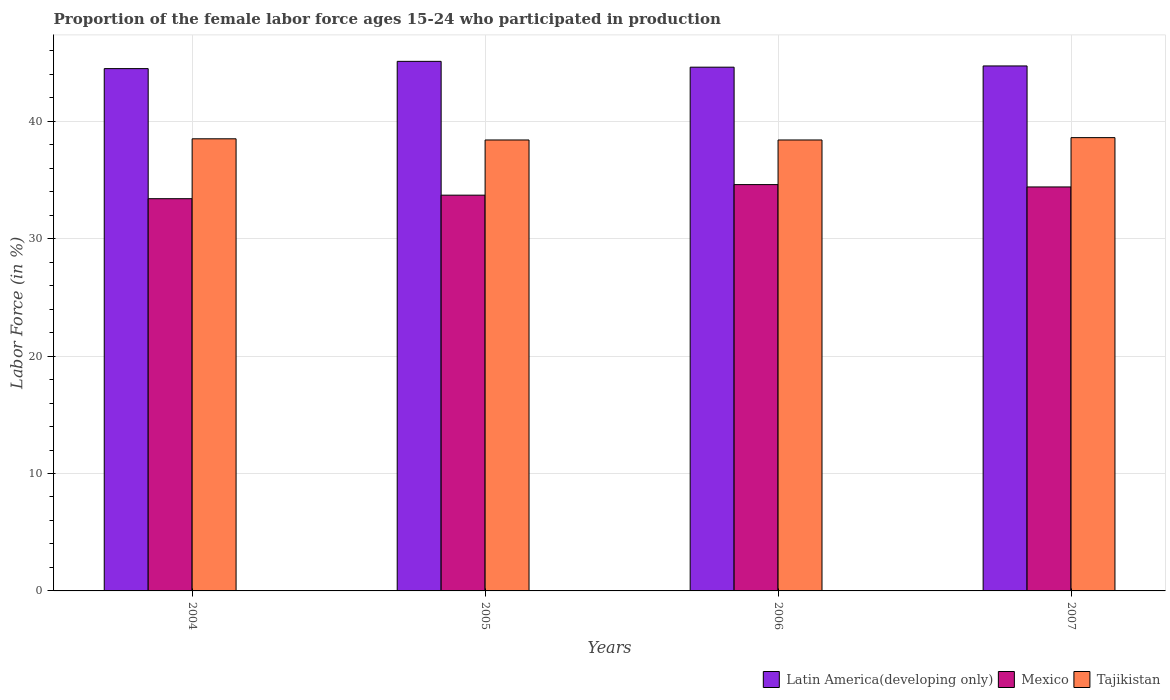How many different coloured bars are there?
Your response must be concise. 3. How many bars are there on the 1st tick from the right?
Offer a terse response. 3. What is the label of the 2nd group of bars from the left?
Your answer should be compact. 2005. In how many cases, is the number of bars for a given year not equal to the number of legend labels?
Provide a short and direct response. 0. What is the proportion of the female labor force who participated in production in Mexico in 2007?
Provide a succinct answer. 34.4. Across all years, what is the maximum proportion of the female labor force who participated in production in Latin America(developing only)?
Make the answer very short. 45.1. Across all years, what is the minimum proportion of the female labor force who participated in production in Mexico?
Your response must be concise. 33.4. In which year was the proportion of the female labor force who participated in production in Latin America(developing only) minimum?
Provide a succinct answer. 2004. What is the total proportion of the female labor force who participated in production in Mexico in the graph?
Offer a very short reply. 136.1. What is the difference between the proportion of the female labor force who participated in production in Tajikistan in 2004 and that in 2005?
Provide a short and direct response. 0.1. What is the difference between the proportion of the female labor force who participated in production in Mexico in 2005 and the proportion of the female labor force who participated in production in Tajikistan in 2004?
Provide a short and direct response. -4.8. What is the average proportion of the female labor force who participated in production in Tajikistan per year?
Your answer should be very brief. 38.48. In the year 2004, what is the difference between the proportion of the female labor force who participated in production in Tajikistan and proportion of the female labor force who participated in production in Latin America(developing only)?
Your answer should be compact. -5.98. In how many years, is the proportion of the female labor force who participated in production in Tajikistan greater than 30 %?
Your answer should be very brief. 4. What is the ratio of the proportion of the female labor force who participated in production in Latin America(developing only) in 2004 to that in 2005?
Make the answer very short. 0.99. Is the difference between the proportion of the female labor force who participated in production in Tajikistan in 2004 and 2006 greater than the difference between the proportion of the female labor force who participated in production in Latin America(developing only) in 2004 and 2006?
Keep it short and to the point. Yes. What is the difference between the highest and the second highest proportion of the female labor force who participated in production in Latin America(developing only)?
Give a very brief answer. 0.39. What is the difference between the highest and the lowest proportion of the female labor force who participated in production in Latin America(developing only)?
Provide a succinct answer. 0.62. What does the 3rd bar from the left in 2006 represents?
Ensure brevity in your answer.  Tajikistan. What does the 1st bar from the right in 2005 represents?
Offer a very short reply. Tajikistan. Is it the case that in every year, the sum of the proportion of the female labor force who participated in production in Mexico and proportion of the female labor force who participated in production in Latin America(developing only) is greater than the proportion of the female labor force who participated in production in Tajikistan?
Your response must be concise. Yes. Does the graph contain any zero values?
Offer a terse response. No. Does the graph contain grids?
Provide a short and direct response. Yes. Where does the legend appear in the graph?
Your response must be concise. Bottom right. How are the legend labels stacked?
Keep it short and to the point. Horizontal. What is the title of the graph?
Offer a terse response. Proportion of the female labor force ages 15-24 who participated in production. What is the Labor Force (in %) of Latin America(developing only) in 2004?
Offer a very short reply. 44.48. What is the Labor Force (in %) in Mexico in 2004?
Make the answer very short. 33.4. What is the Labor Force (in %) of Tajikistan in 2004?
Keep it short and to the point. 38.5. What is the Labor Force (in %) in Latin America(developing only) in 2005?
Provide a succinct answer. 45.1. What is the Labor Force (in %) in Mexico in 2005?
Provide a short and direct response. 33.7. What is the Labor Force (in %) in Tajikistan in 2005?
Keep it short and to the point. 38.4. What is the Labor Force (in %) of Latin America(developing only) in 2006?
Make the answer very short. 44.6. What is the Labor Force (in %) of Mexico in 2006?
Offer a terse response. 34.6. What is the Labor Force (in %) of Tajikistan in 2006?
Your answer should be compact. 38.4. What is the Labor Force (in %) of Latin America(developing only) in 2007?
Keep it short and to the point. 44.7. What is the Labor Force (in %) in Mexico in 2007?
Ensure brevity in your answer.  34.4. What is the Labor Force (in %) in Tajikistan in 2007?
Offer a very short reply. 38.6. Across all years, what is the maximum Labor Force (in %) in Latin America(developing only)?
Your answer should be compact. 45.1. Across all years, what is the maximum Labor Force (in %) of Mexico?
Your answer should be compact. 34.6. Across all years, what is the maximum Labor Force (in %) of Tajikistan?
Ensure brevity in your answer.  38.6. Across all years, what is the minimum Labor Force (in %) in Latin America(developing only)?
Make the answer very short. 44.48. Across all years, what is the minimum Labor Force (in %) in Mexico?
Ensure brevity in your answer.  33.4. Across all years, what is the minimum Labor Force (in %) in Tajikistan?
Provide a short and direct response. 38.4. What is the total Labor Force (in %) in Latin America(developing only) in the graph?
Provide a succinct answer. 178.88. What is the total Labor Force (in %) in Mexico in the graph?
Keep it short and to the point. 136.1. What is the total Labor Force (in %) of Tajikistan in the graph?
Offer a terse response. 153.9. What is the difference between the Labor Force (in %) of Latin America(developing only) in 2004 and that in 2005?
Keep it short and to the point. -0.62. What is the difference between the Labor Force (in %) in Latin America(developing only) in 2004 and that in 2006?
Make the answer very short. -0.12. What is the difference between the Labor Force (in %) of Latin America(developing only) in 2004 and that in 2007?
Give a very brief answer. -0.23. What is the difference between the Labor Force (in %) in Mexico in 2004 and that in 2007?
Your answer should be compact. -1. What is the difference between the Labor Force (in %) in Tajikistan in 2004 and that in 2007?
Give a very brief answer. -0.1. What is the difference between the Labor Force (in %) in Latin America(developing only) in 2005 and that in 2006?
Keep it short and to the point. 0.5. What is the difference between the Labor Force (in %) of Mexico in 2005 and that in 2006?
Your response must be concise. -0.9. What is the difference between the Labor Force (in %) in Tajikistan in 2005 and that in 2006?
Offer a terse response. 0. What is the difference between the Labor Force (in %) in Latin America(developing only) in 2005 and that in 2007?
Offer a very short reply. 0.39. What is the difference between the Labor Force (in %) in Latin America(developing only) in 2006 and that in 2007?
Your response must be concise. -0.1. What is the difference between the Labor Force (in %) in Latin America(developing only) in 2004 and the Labor Force (in %) in Mexico in 2005?
Provide a succinct answer. 10.78. What is the difference between the Labor Force (in %) in Latin America(developing only) in 2004 and the Labor Force (in %) in Tajikistan in 2005?
Your answer should be very brief. 6.08. What is the difference between the Labor Force (in %) in Latin America(developing only) in 2004 and the Labor Force (in %) in Mexico in 2006?
Ensure brevity in your answer.  9.88. What is the difference between the Labor Force (in %) of Latin America(developing only) in 2004 and the Labor Force (in %) of Tajikistan in 2006?
Provide a succinct answer. 6.08. What is the difference between the Labor Force (in %) of Latin America(developing only) in 2004 and the Labor Force (in %) of Mexico in 2007?
Offer a very short reply. 10.08. What is the difference between the Labor Force (in %) of Latin America(developing only) in 2004 and the Labor Force (in %) of Tajikistan in 2007?
Give a very brief answer. 5.88. What is the difference between the Labor Force (in %) in Mexico in 2004 and the Labor Force (in %) in Tajikistan in 2007?
Give a very brief answer. -5.2. What is the difference between the Labor Force (in %) in Latin America(developing only) in 2005 and the Labor Force (in %) in Mexico in 2006?
Keep it short and to the point. 10.5. What is the difference between the Labor Force (in %) of Latin America(developing only) in 2005 and the Labor Force (in %) of Tajikistan in 2006?
Make the answer very short. 6.7. What is the difference between the Labor Force (in %) in Mexico in 2005 and the Labor Force (in %) in Tajikistan in 2006?
Make the answer very short. -4.7. What is the difference between the Labor Force (in %) of Latin America(developing only) in 2005 and the Labor Force (in %) of Mexico in 2007?
Ensure brevity in your answer.  10.7. What is the difference between the Labor Force (in %) in Latin America(developing only) in 2005 and the Labor Force (in %) in Tajikistan in 2007?
Your answer should be compact. 6.5. What is the difference between the Labor Force (in %) in Mexico in 2005 and the Labor Force (in %) in Tajikistan in 2007?
Offer a terse response. -4.9. What is the difference between the Labor Force (in %) in Latin America(developing only) in 2006 and the Labor Force (in %) in Mexico in 2007?
Ensure brevity in your answer.  10.2. What is the difference between the Labor Force (in %) of Latin America(developing only) in 2006 and the Labor Force (in %) of Tajikistan in 2007?
Your answer should be very brief. 6. What is the difference between the Labor Force (in %) of Mexico in 2006 and the Labor Force (in %) of Tajikistan in 2007?
Offer a very short reply. -4. What is the average Labor Force (in %) of Latin America(developing only) per year?
Provide a short and direct response. 44.72. What is the average Labor Force (in %) of Mexico per year?
Ensure brevity in your answer.  34.02. What is the average Labor Force (in %) in Tajikistan per year?
Provide a short and direct response. 38.48. In the year 2004, what is the difference between the Labor Force (in %) in Latin America(developing only) and Labor Force (in %) in Mexico?
Provide a short and direct response. 11.08. In the year 2004, what is the difference between the Labor Force (in %) in Latin America(developing only) and Labor Force (in %) in Tajikistan?
Your answer should be compact. 5.98. In the year 2005, what is the difference between the Labor Force (in %) of Latin America(developing only) and Labor Force (in %) of Mexico?
Your answer should be compact. 11.4. In the year 2005, what is the difference between the Labor Force (in %) of Latin America(developing only) and Labor Force (in %) of Tajikistan?
Ensure brevity in your answer.  6.7. In the year 2006, what is the difference between the Labor Force (in %) of Latin America(developing only) and Labor Force (in %) of Mexico?
Your answer should be very brief. 10. In the year 2006, what is the difference between the Labor Force (in %) in Latin America(developing only) and Labor Force (in %) in Tajikistan?
Provide a short and direct response. 6.2. In the year 2007, what is the difference between the Labor Force (in %) of Latin America(developing only) and Labor Force (in %) of Mexico?
Offer a very short reply. 10.3. In the year 2007, what is the difference between the Labor Force (in %) of Latin America(developing only) and Labor Force (in %) of Tajikistan?
Give a very brief answer. 6.1. What is the ratio of the Labor Force (in %) in Latin America(developing only) in 2004 to that in 2005?
Offer a very short reply. 0.99. What is the ratio of the Labor Force (in %) in Mexico in 2004 to that in 2005?
Provide a short and direct response. 0.99. What is the ratio of the Labor Force (in %) in Tajikistan in 2004 to that in 2005?
Give a very brief answer. 1. What is the ratio of the Labor Force (in %) in Mexico in 2004 to that in 2006?
Keep it short and to the point. 0.97. What is the ratio of the Labor Force (in %) in Tajikistan in 2004 to that in 2006?
Make the answer very short. 1. What is the ratio of the Labor Force (in %) in Mexico in 2004 to that in 2007?
Ensure brevity in your answer.  0.97. What is the ratio of the Labor Force (in %) of Latin America(developing only) in 2005 to that in 2006?
Your answer should be very brief. 1.01. What is the ratio of the Labor Force (in %) of Tajikistan in 2005 to that in 2006?
Provide a succinct answer. 1. What is the ratio of the Labor Force (in %) of Latin America(developing only) in 2005 to that in 2007?
Make the answer very short. 1.01. What is the ratio of the Labor Force (in %) in Mexico in 2005 to that in 2007?
Your answer should be compact. 0.98. What is the ratio of the Labor Force (in %) of Latin America(developing only) in 2006 to that in 2007?
Offer a very short reply. 1. What is the ratio of the Labor Force (in %) in Tajikistan in 2006 to that in 2007?
Offer a very short reply. 0.99. What is the difference between the highest and the second highest Labor Force (in %) of Latin America(developing only)?
Give a very brief answer. 0.39. What is the difference between the highest and the second highest Labor Force (in %) in Tajikistan?
Make the answer very short. 0.1. What is the difference between the highest and the lowest Labor Force (in %) of Latin America(developing only)?
Your response must be concise. 0.62. What is the difference between the highest and the lowest Labor Force (in %) in Mexico?
Your response must be concise. 1.2. 